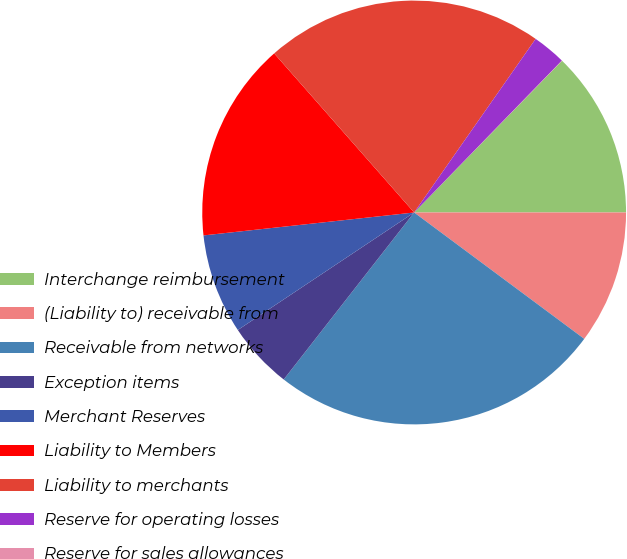Convert chart to OTSL. <chart><loc_0><loc_0><loc_500><loc_500><pie_chart><fcel>Interchange reimbursement<fcel>(Liability to) receivable from<fcel>Receivable from networks<fcel>Exception items<fcel>Merchant Reserves<fcel>Liability to Members<fcel>Liability to merchants<fcel>Reserve for operating losses<fcel>Reserve for sales allowances<nl><fcel>12.7%<fcel>10.17%<fcel>25.38%<fcel>5.09%<fcel>7.63%<fcel>15.24%<fcel>21.2%<fcel>2.56%<fcel>0.02%<nl></chart> 